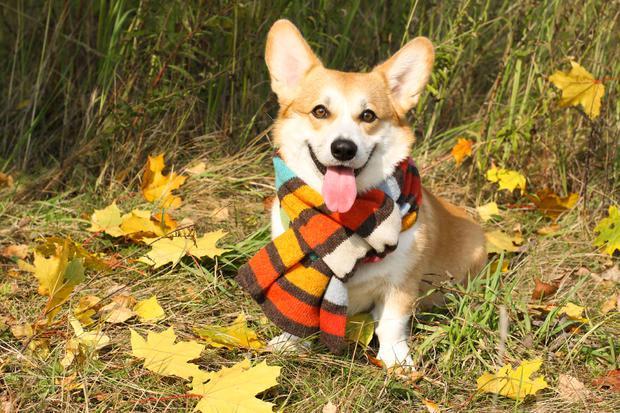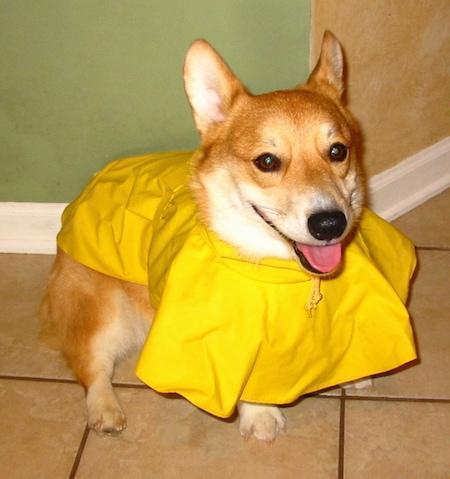The first image is the image on the left, the second image is the image on the right. Examine the images to the left and right. Is the description "Two corgies with similar tan coloring and ears standing up have smiling expressions and tongues hanging out." accurate? Answer yes or no. Yes. The first image is the image on the left, the second image is the image on the right. Examine the images to the left and right. Is the description "The right image includes a tan and white dog that is sitting upright on a white background." accurate? Answer yes or no. No. 